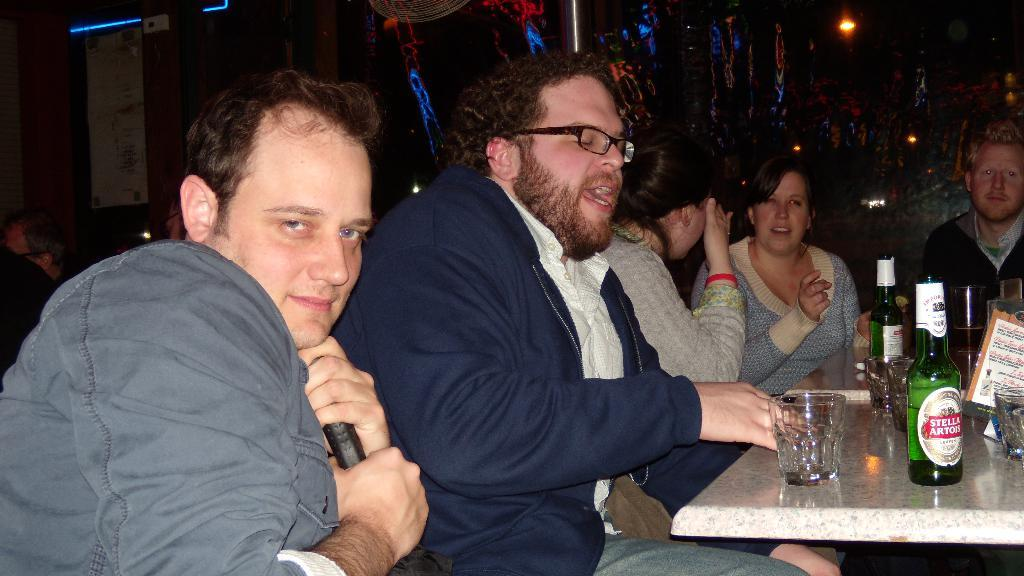What are the people in the image doing? The people in the image are sitting. What objects can be seen on the table in the image? There are bottles and glasses on the table in the image. What type of sock is hanging from the ceiling in the image? There is no sock present in the image. How many crates are stacked in the corner of the room in the image? There is no crate present in the image. 